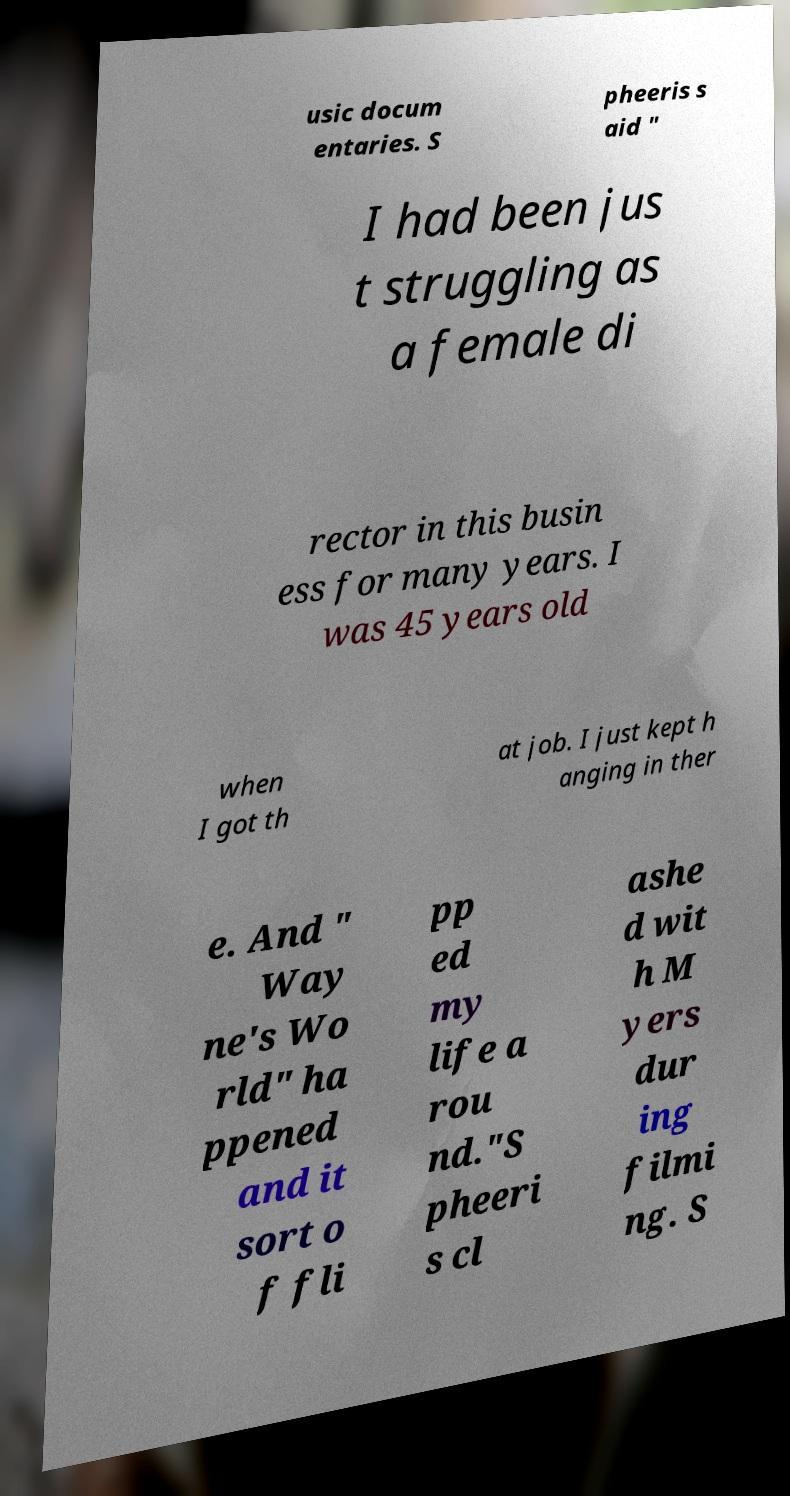Please read and relay the text visible in this image. What does it say? usic docum entaries. S pheeris s aid " I had been jus t struggling as a female di rector in this busin ess for many years. I was 45 years old when I got th at job. I just kept h anging in ther e. And " Way ne's Wo rld" ha ppened and it sort o f fli pp ed my life a rou nd."S pheeri s cl ashe d wit h M yers dur ing filmi ng. S 